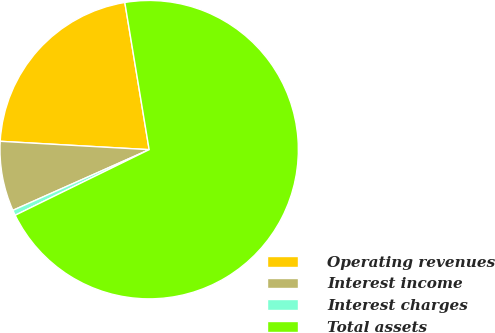Convert chart to OTSL. <chart><loc_0><loc_0><loc_500><loc_500><pie_chart><fcel>Operating revenues<fcel>Interest income<fcel>Interest charges<fcel>Total assets<nl><fcel>21.5%<fcel>7.56%<fcel>0.58%<fcel>70.36%<nl></chart> 